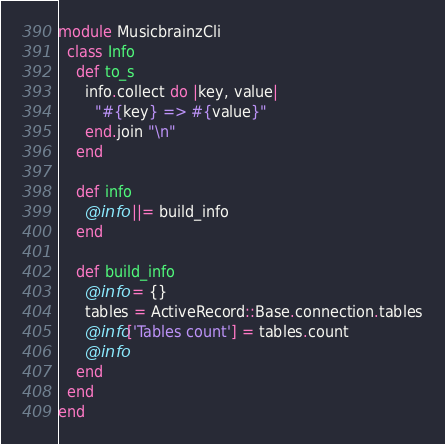<code> <loc_0><loc_0><loc_500><loc_500><_Ruby_>module MusicbrainzCli
  class Info
    def to_s
      info.collect do |key, value|
        "#{key} => #{value}"
      end.join "\n"
    end

    def info
      @info ||= build_info
    end

    def build_info
      @info = {}
      tables = ActiveRecord::Base.connection.tables
      @info['Tables count'] = tables.count
      @info
    end
  end
end
</code> 